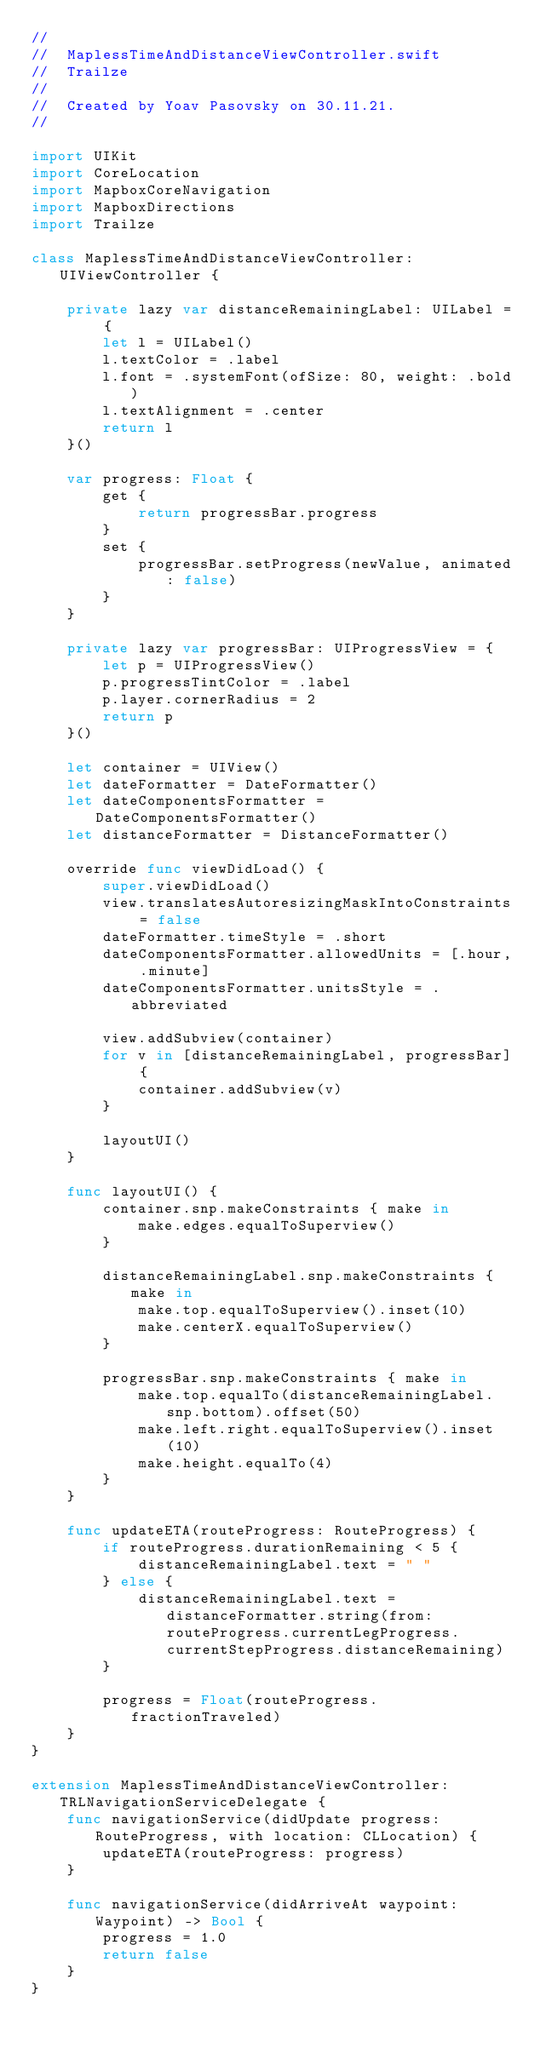<code> <loc_0><loc_0><loc_500><loc_500><_Swift_>//
//  MaplessTimeAndDistanceViewController.swift
//  Trailze
//
//  Created by Yoav Pasovsky on 30.11.21.
//

import UIKit
import CoreLocation
import MapboxCoreNavigation
import MapboxDirections
import Trailze

class MaplessTimeAndDistanceViewController: UIViewController {
    
    private lazy var distanceRemainingLabel: UILabel = {
        let l = UILabel()
        l.textColor = .label
        l.font = .systemFont(ofSize: 80, weight: .bold)
        l.textAlignment = .center
        return l
    }()
        
    var progress: Float {
        get {
            return progressBar.progress
        }
        set {
            progressBar.setProgress(newValue, animated: false)
        }
    }
    
    private lazy var progressBar: UIProgressView = {
        let p = UIProgressView()
        p.progressTintColor = .label
        p.layer.cornerRadius = 2
        return p
    }()
    
    let container = UIView()
    let dateFormatter = DateFormatter()
    let dateComponentsFormatter = DateComponentsFormatter()
    let distanceFormatter = DistanceFormatter()
    
    override func viewDidLoad() {
        super.viewDidLoad()
        view.translatesAutoresizingMaskIntoConstraints = false
        dateFormatter.timeStyle = .short
        dateComponentsFormatter.allowedUnits = [.hour, .minute]
        dateComponentsFormatter.unitsStyle = .abbreviated
        
        view.addSubview(container)
        for v in [distanceRemainingLabel, progressBar] {
            container.addSubview(v)
        }
        
        layoutUI()
    }
    
    func layoutUI() {
        container.snp.makeConstraints { make in
            make.edges.equalToSuperview()
        }
        
        distanceRemainingLabel.snp.makeConstraints { make in
            make.top.equalToSuperview().inset(10)
            make.centerX.equalToSuperview()
        }
        
        progressBar.snp.makeConstraints { make in
            make.top.equalTo(distanceRemainingLabel.snp.bottom).offset(50)
            make.left.right.equalToSuperview().inset(10)
            make.height.equalTo(4)
        }
    }
    
    func updateETA(routeProgress: RouteProgress) {
        if routeProgress.durationRemaining < 5 {
            distanceRemainingLabel.text = " "
        } else {
            distanceRemainingLabel.text = distanceFormatter.string(from: routeProgress.currentLegProgress.currentStepProgress.distanceRemaining)
        }
        
        progress = Float(routeProgress.fractionTraveled)
    }
}

extension MaplessTimeAndDistanceViewController: TRLNavigationServiceDelegate {
    func navigationService(didUpdate progress: RouteProgress, with location: CLLocation) {
        updateETA(routeProgress: progress)
    }
    
    func navigationService(didArriveAt waypoint: Waypoint) -> Bool {
        progress = 1.0
        return false
    }
}
</code> 